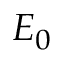Convert formula to latex. <formula><loc_0><loc_0><loc_500><loc_500>E _ { 0 }</formula> 